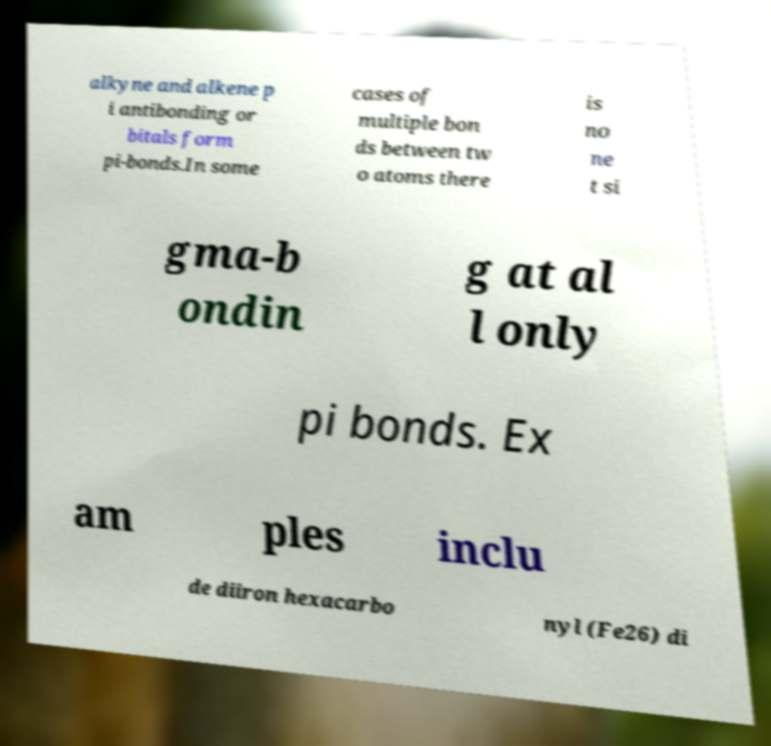Can you accurately transcribe the text from the provided image for me? alkyne and alkene p i antibonding or bitals form pi-bonds.In some cases of multiple bon ds between tw o atoms there is no ne t si gma-b ondin g at al l only pi bonds. Ex am ples inclu de diiron hexacarbo nyl (Fe26) di 